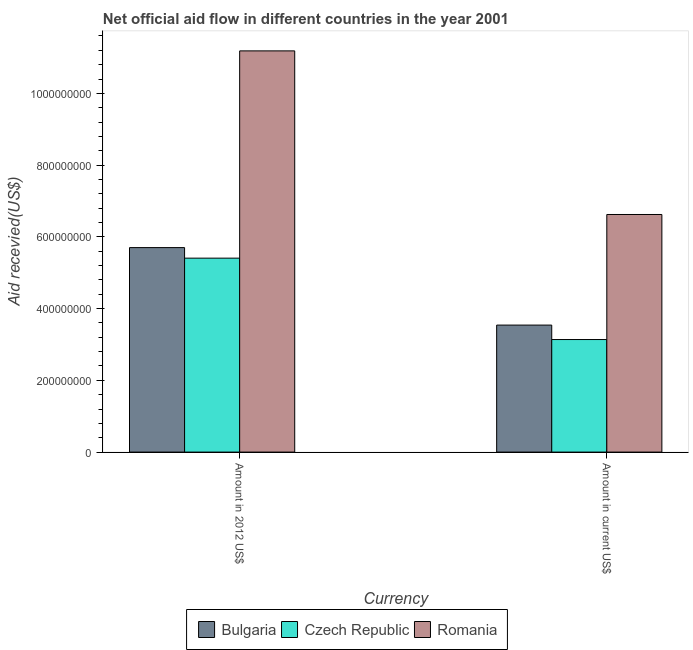How many different coloured bars are there?
Ensure brevity in your answer.  3. How many groups of bars are there?
Give a very brief answer. 2. Are the number of bars per tick equal to the number of legend labels?
Your answer should be very brief. Yes. How many bars are there on the 2nd tick from the left?
Keep it short and to the point. 3. What is the label of the 1st group of bars from the left?
Keep it short and to the point. Amount in 2012 US$. What is the amount of aid received(expressed in us$) in Romania?
Offer a very short reply. 6.62e+08. Across all countries, what is the maximum amount of aid received(expressed in 2012 us$)?
Give a very brief answer. 1.12e+09. Across all countries, what is the minimum amount of aid received(expressed in 2012 us$)?
Provide a short and direct response. 5.41e+08. In which country was the amount of aid received(expressed in 2012 us$) maximum?
Your answer should be very brief. Romania. In which country was the amount of aid received(expressed in us$) minimum?
Your answer should be compact. Czech Republic. What is the total amount of aid received(expressed in 2012 us$) in the graph?
Your response must be concise. 2.23e+09. What is the difference between the amount of aid received(expressed in us$) in Bulgaria and that in Czech Republic?
Offer a very short reply. 4.03e+07. What is the difference between the amount of aid received(expressed in us$) in Bulgaria and the amount of aid received(expressed in 2012 us$) in Czech Republic?
Keep it short and to the point. -1.87e+08. What is the average amount of aid received(expressed in us$) per country?
Your answer should be compact. 4.43e+08. What is the difference between the amount of aid received(expressed in 2012 us$) and amount of aid received(expressed in us$) in Bulgaria?
Make the answer very short. 2.16e+08. In how many countries, is the amount of aid received(expressed in us$) greater than 560000000 US$?
Offer a terse response. 1. What is the ratio of the amount of aid received(expressed in us$) in Bulgaria to that in Czech Republic?
Ensure brevity in your answer.  1.13. Is the amount of aid received(expressed in 2012 us$) in Czech Republic less than that in Romania?
Your answer should be very brief. Yes. What does the 1st bar from the left in Amount in current US$ represents?
Provide a succinct answer. Bulgaria. What does the 1st bar from the right in Amount in current US$ represents?
Offer a very short reply. Romania. How many bars are there?
Your answer should be compact. 6. Are the values on the major ticks of Y-axis written in scientific E-notation?
Offer a terse response. No. Does the graph contain any zero values?
Provide a short and direct response. No. Where does the legend appear in the graph?
Provide a succinct answer. Bottom center. How are the legend labels stacked?
Keep it short and to the point. Horizontal. What is the title of the graph?
Make the answer very short. Net official aid flow in different countries in the year 2001. What is the label or title of the X-axis?
Keep it short and to the point. Currency. What is the label or title of the Y-axis?
Give a very brief answer. Aid recevied(US$). What is the Aid recevied(US$) of Bulgaria in Amount in 2012 US$?
Your response must be concise. 5.70e+08. What is the Aid recevied(US$) of Czech Republic in Amount in 2012 US$?
Your response must be concise. 5.41e+08. What is the Aid recevied(US$) in Romania in Amount in 2012 US$?
Provide a short and direct response. 1.12e+09. What is the Aid recevied(US$) in Bulgaria in Amount in current US$?
Your response must be concise. 3.54e+08. What is the Aid recevied(US$) of Czech Republic in Amount in current US$?
Provide a succinct answer. 3.14e+08. What is the Aid recevied(US$) of Romania in Amount in current US$?
Offer a terse response. 6.62e+08. Across all Currency, what is the maximum Aid recevied(US$) of Bulgaria?
Ensure brevity in your answer.  5.70e+08. Across all Currency, what is the maximum Aid recevied(US$) in Czech Republic?
Your response must be concise. 5.41e+08. Across all Currency, what is the maximum Aid recevied(US$) of Romania?
Offer a very short reply. 1.12e+09. Across all Currency, what is the minimum Aid recevied(US$) in Bulgaria?
Your answer should be compact. 3.54e+08. Across all Currency, what is the minimum Aid recevied(US$) of Czech Republic?
Your answer should be compact. 3.14e+08. Across all Currency, what is the minimum Aid recevied(US$) in Romania?
Give a very brief answer. 6.62e+08. What is the total Aid recevied(US$) in Bulgaria in the graph?
Offer a terse response. 9.24e+08. What is the total Aid recevied(US$) of Czech Republic in the graph?
Your response must be concise. 8.54e+08. What is the total Aid recevied(US$) in Romania in the graph?
Keep it short and to the point. 1.78e+09. What is the difference between the Aid recevied(US$) in Bulgaria in Amount in 2012 US$ and that in Amount in current US$?
Make the answer very short. 2.16e+08. What is the difference between the Aid recevied(US$) in Czech Republic in Amount in 2012 US$ and that in Amount in current US$?
Your response must be concise. 2.27e+08. What is the difference between the Aid recevied(US$) in Romania in Amount in 2012 US$ and that in Amount in current US$?
Offer a terse response. 4.56e+08. What is the difference between the Aid recevied(US$) in Bulgaria in Amount in 2012 US$ and the Aid recevied(US$) in Czech Republic in Amount in current US$?
Give a very brief answer. 2.56e+08. What is the difference between the Aid recevied(US$) of Bulgaria in Amount in 2012 US$ and the Aid recevied(US$) of Romania in Amount in current US$?
Provide a short and direct response. -9.23e+07. What is the difference between the Aid recevied(US$) of Czech Republic in Amount in 2012 US$ and the Aid recevied(US$) of Romania in Amount in current US$?
Provide a short and direct response. -1.22e+08. What is the average Aid recevied(US$) of Bulgaria per Currency?
Offer a terse response. 4.62e+08. What is the average Aid recevied(US$) in Czech Republic per Currency?
Make the answer very short. 4.27e+08. What is the average Aid recevied(US$) of Romania per Currency?
Offer a terse response. 8.90e+08. What is the difference between the Aid recevied(US$) in Bulgaria and Aid recevied(US$) in Czech Republic in Amount in 2012 US$?
Your response must be concise. 2.94e+07. What is the difference between the Aid recevied(US$) in Bulgaria and Aid recevied(US$) in Romania in Amount in 2012 US$?
Offer a very short reply. -5.48e+08. What is the difference between the Aid recevied(US$) of Czech Republic and Aid recevied(US$) of Romania in Amount in 2012 US$?
Offer a terse response. -5.78e+08. What is the difference between the Aid recevied(US$) of Bulgaria and Aid recevied(US$) of Czech Republic in Amount in current US$?
Give a very brief answer. 4.03e+07. What is the difference between the Aid recevied(US$) of Bulgaria and Aid recevied(US$) of Romania in Amount in current US$?
Give a very brief answer. -3.08e+08. What is the difference between the Aid recevied(US$) in Czech Republic and Aid recevied(US$) in Romania in Amount in current US$?
Ensure brevity in your answer.  -3.49e+08. What is the ratio of the Aid recevied(US$) in Bulgaria in Amount in 2012 US$ to that in Amount in current US$?
Provide a succinct answer. 1.61. What is the ratio of the Aid recevied(US$) in Czech Republic in Amount in 2012 US$ to that in Amount in current US$?
Ensure brevity in your answer.  1.72. What is the ratio of the Aid recevied(US$) of Romania in Amount in 2012 US$ to that in Amount in current US$?
Your response must be concise. 1.69. What is the difference between the highest and the second highest Aid recevied(US$) in Bulgaria?
Keep it short and to the point. 2.16e+08. What is the difference between the highest and the second highest Aid recevied(US$) in Czech Republic?
Provide a short and direct response. 2.27e+08. What is the difference between the highest and the second highest Aid recevied(US$) in Romania?
Offer a very short reply. 4.56e+08. What is the difference between the highest and the lowest Aid recevied(US$) in Bulgaria?
Offer a terse response. 2.16e+08. What is the difference between the highest and the lowest Aid recevied(US$) in Czech Republic?
Your response must be concise. 2.27e+08. What is the difference between the highest and the lowest Aid recevied(US$) of Romania?
Keep it short and to the point. 4.56e+08. 